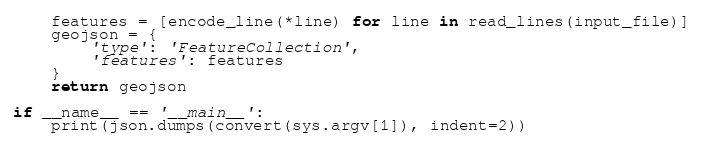<code> <loc_0><loc_0><loc_500><loc_500><_Python_>    features = [encode_line(*line) for line in read_lines(input_file)]
    geojson = {
        'type': 'FeatureCollection',
        'features': features
    }
    return geojson

if __name__ == '__main__':
    print(json.dumps(convert(sys.argv[1]), indent=2))
</code> 